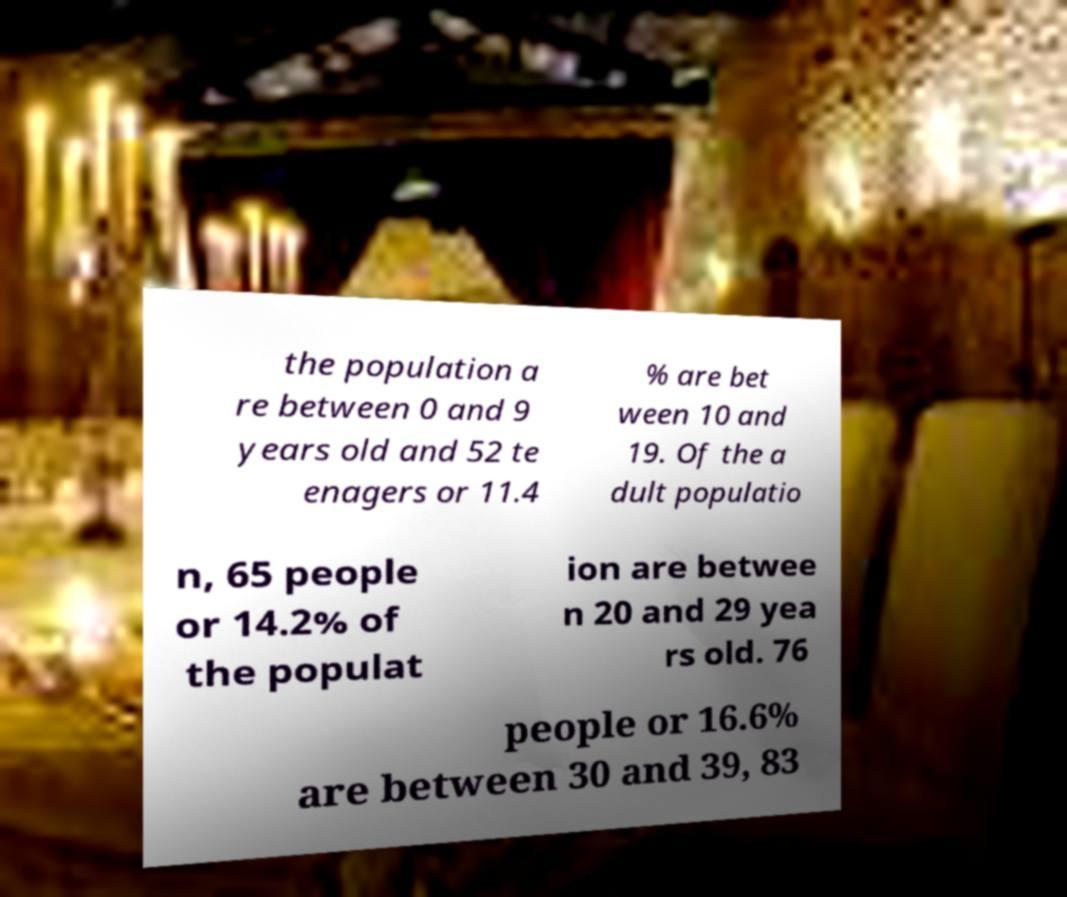Could you extract and type out the text from this image? the population a re between 0 and 9 years old and 52 te enagers or 11.4 % are bet ween 10 and 19. Of the a dult populatio n, 65 people or 14.2% of the populat ion are betwee n 20 and 29 yea rs old. 76 people or 16.6% are between 30 and 39, 83 